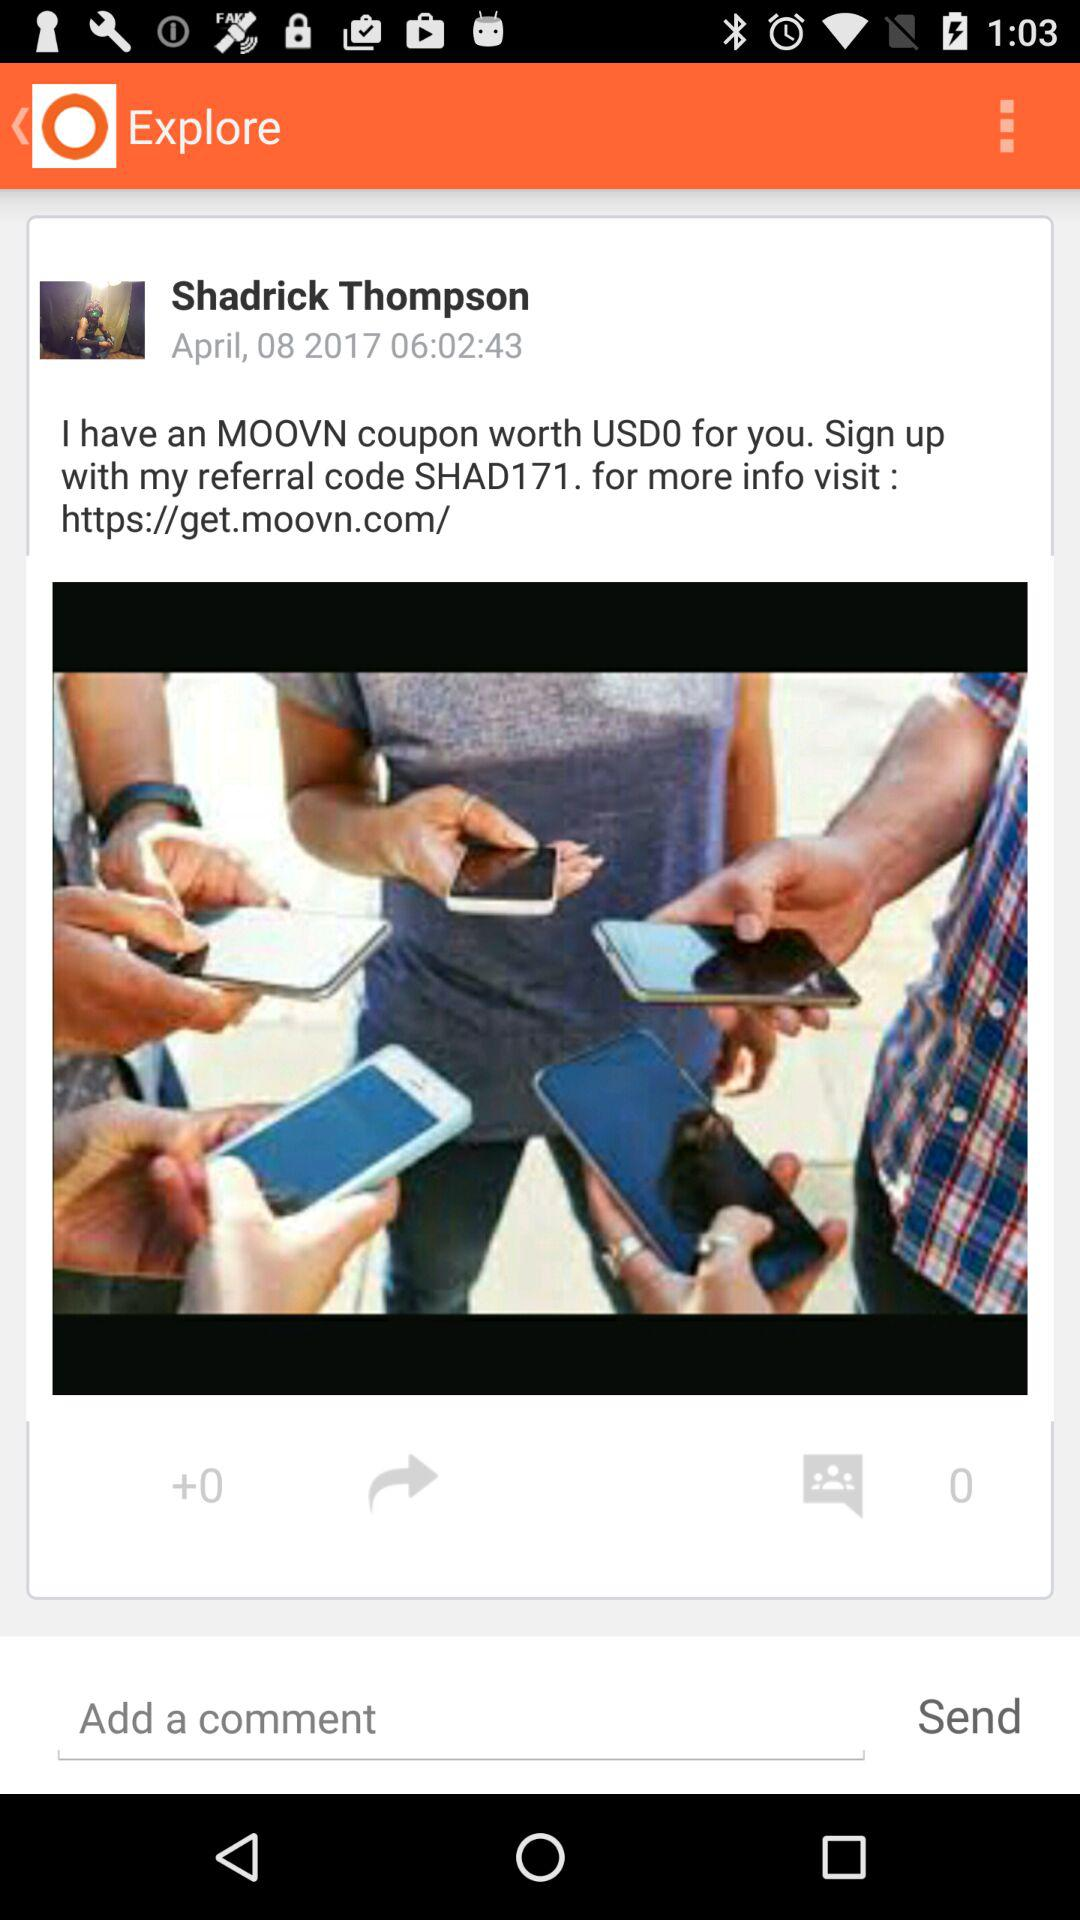How many comments are there? There are 0 comments. 